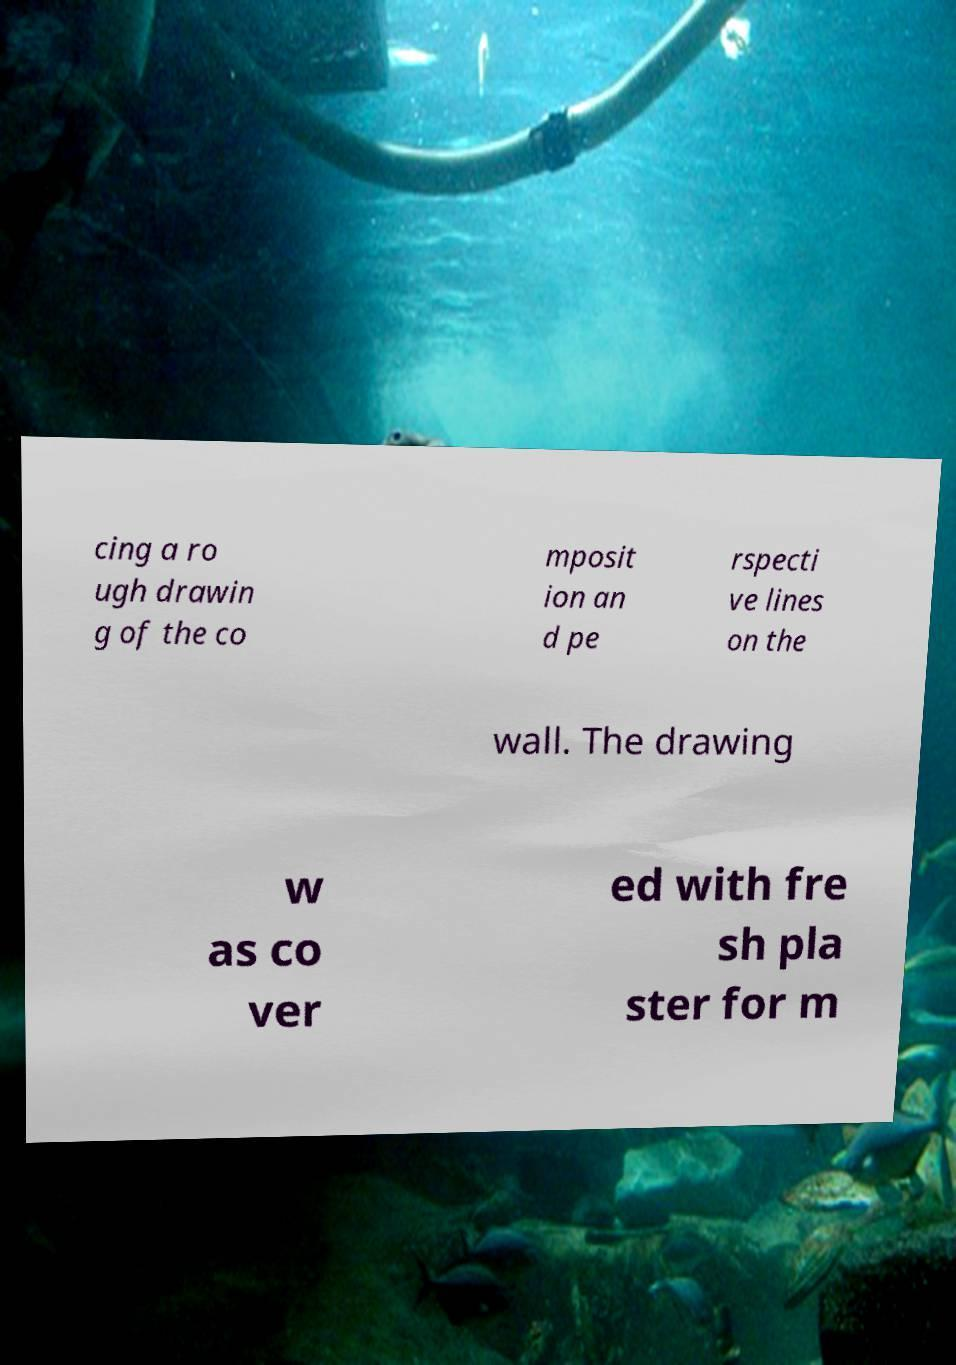Can you read and provide the text displayed in the image?This photo seems to have some interesting text. Can you extract and type it out for me? cing a ro ugh drawin g of the co mposit ion an d pe rspecti ve lines on the wall. The drawing w as co ver ed with fre sh pla ster for m 